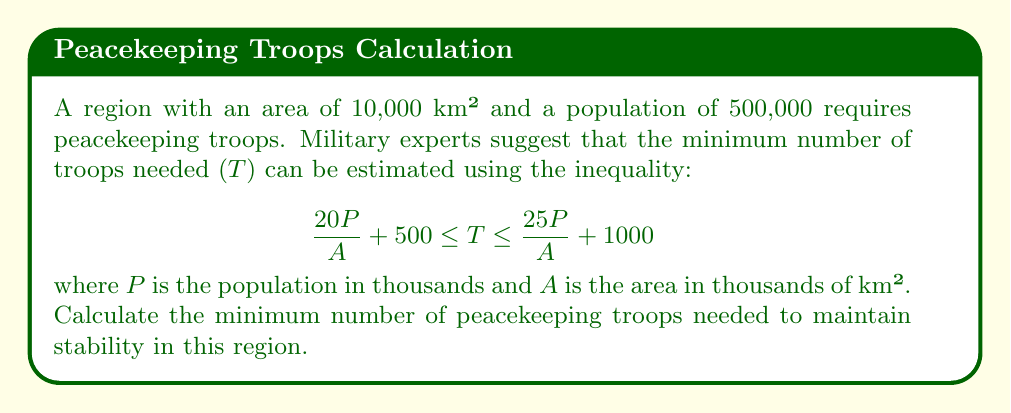Help me with this question. 1. Identify the given values:
   P = 500 (population in thousands)
   A = 10 (area in thousands of km²)

2. Substitute these values into the left side of the inequality:
   $$ \frac{20P}{A} + 500 \leq T $$
   $$ \frac{20(500)}{10} + 500 \leq T $$

3. Simplify:
   $$ 1000 + 500 \leq T $$
   $$ 1500 \leq T $$

4. Since we're looking for the minimum number of troops, we take the lower bound of the inequality.

5. Round up to the nearest whole number, as we can't have fractional troops.
Answer: 1500 troops 